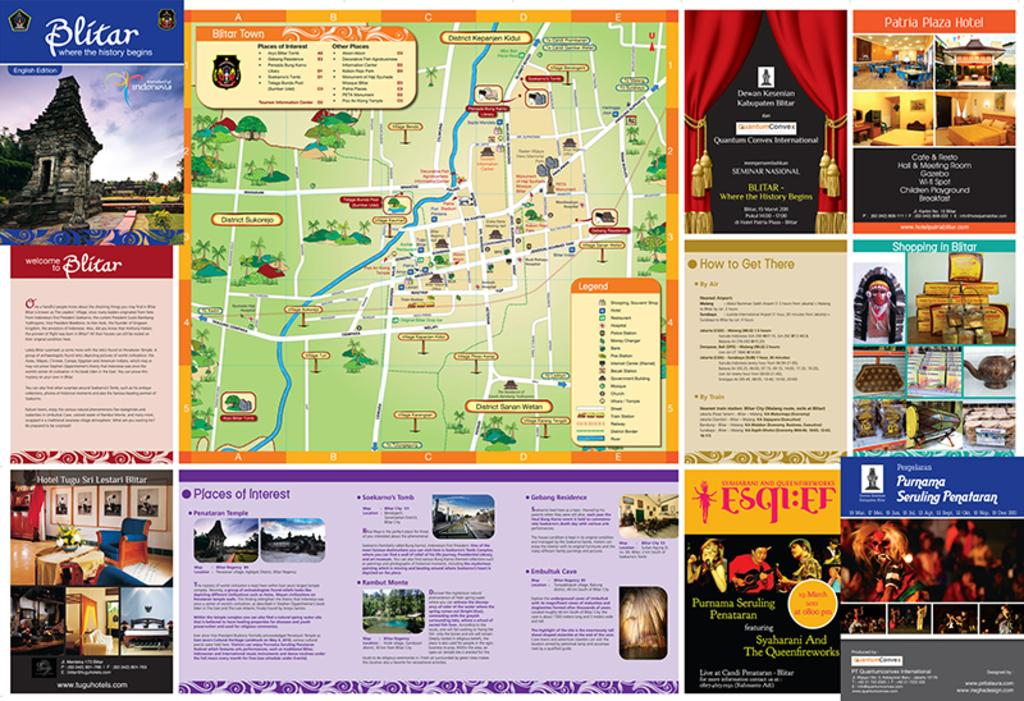Provide a one-sentence caption for the provided image. it's a map of a theme park with information on it. 